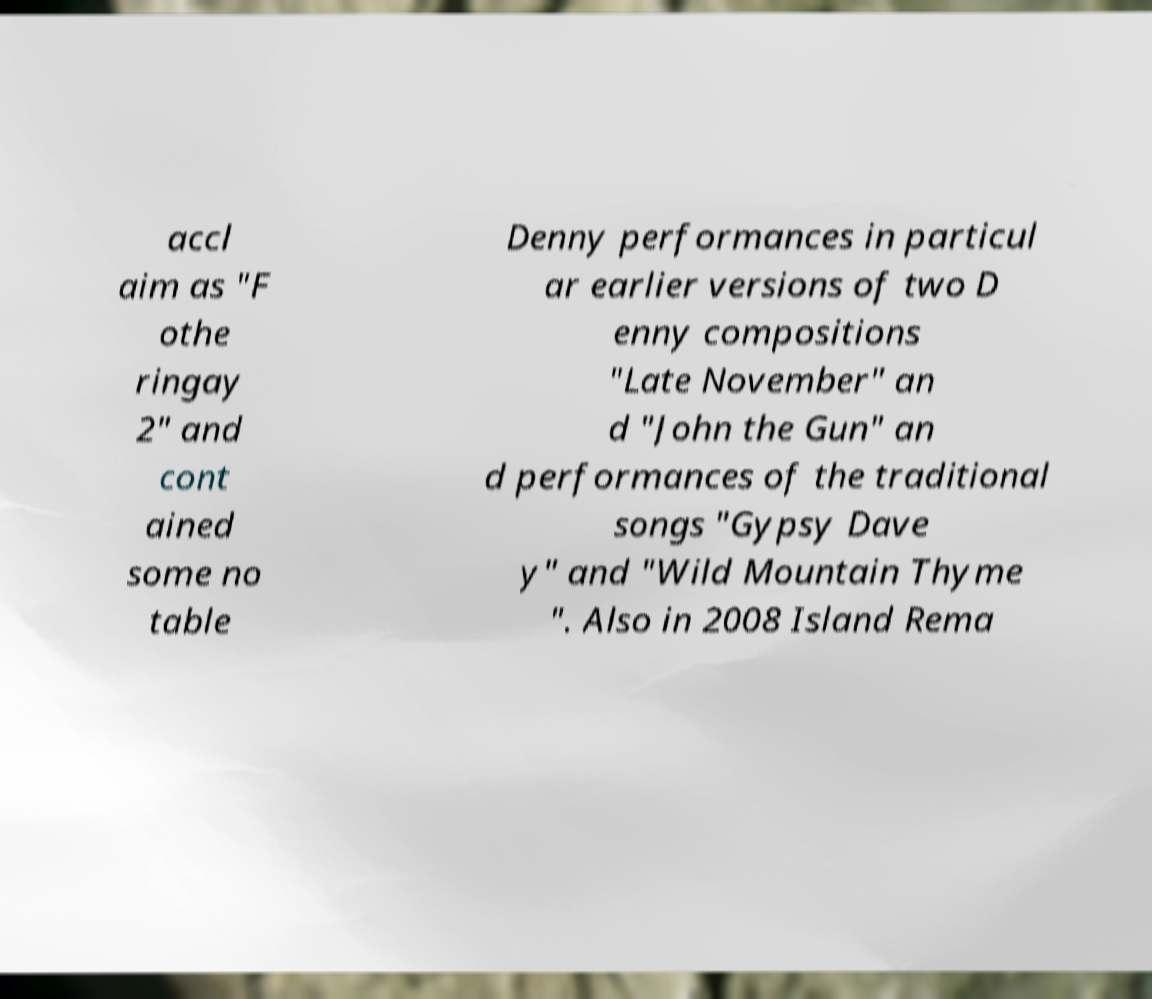Please identify and transcribe the text found in this image. accl aim as "F othe ringay 2" and cont ained some no table Denny performances in particul ar earlier versions of two D enny compositions "Late November" an d "John the Gun" an d performances of the traditional songs "Gypsy Dave y" and "Wild Mountain Thyme ". Also in 2008 Island Rema 